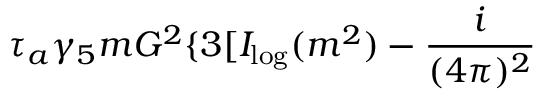<formula> <loc_0><loc_0><loc_500><loc_500>\tau _ { a } \gamma _ { 5 } m G ^ { 2 } \{ 3 [ I _ { \log } ( m ^ { 2 } ) - \frac { i } { ( 4 \pi ) ^ { 2 } }</formula> 